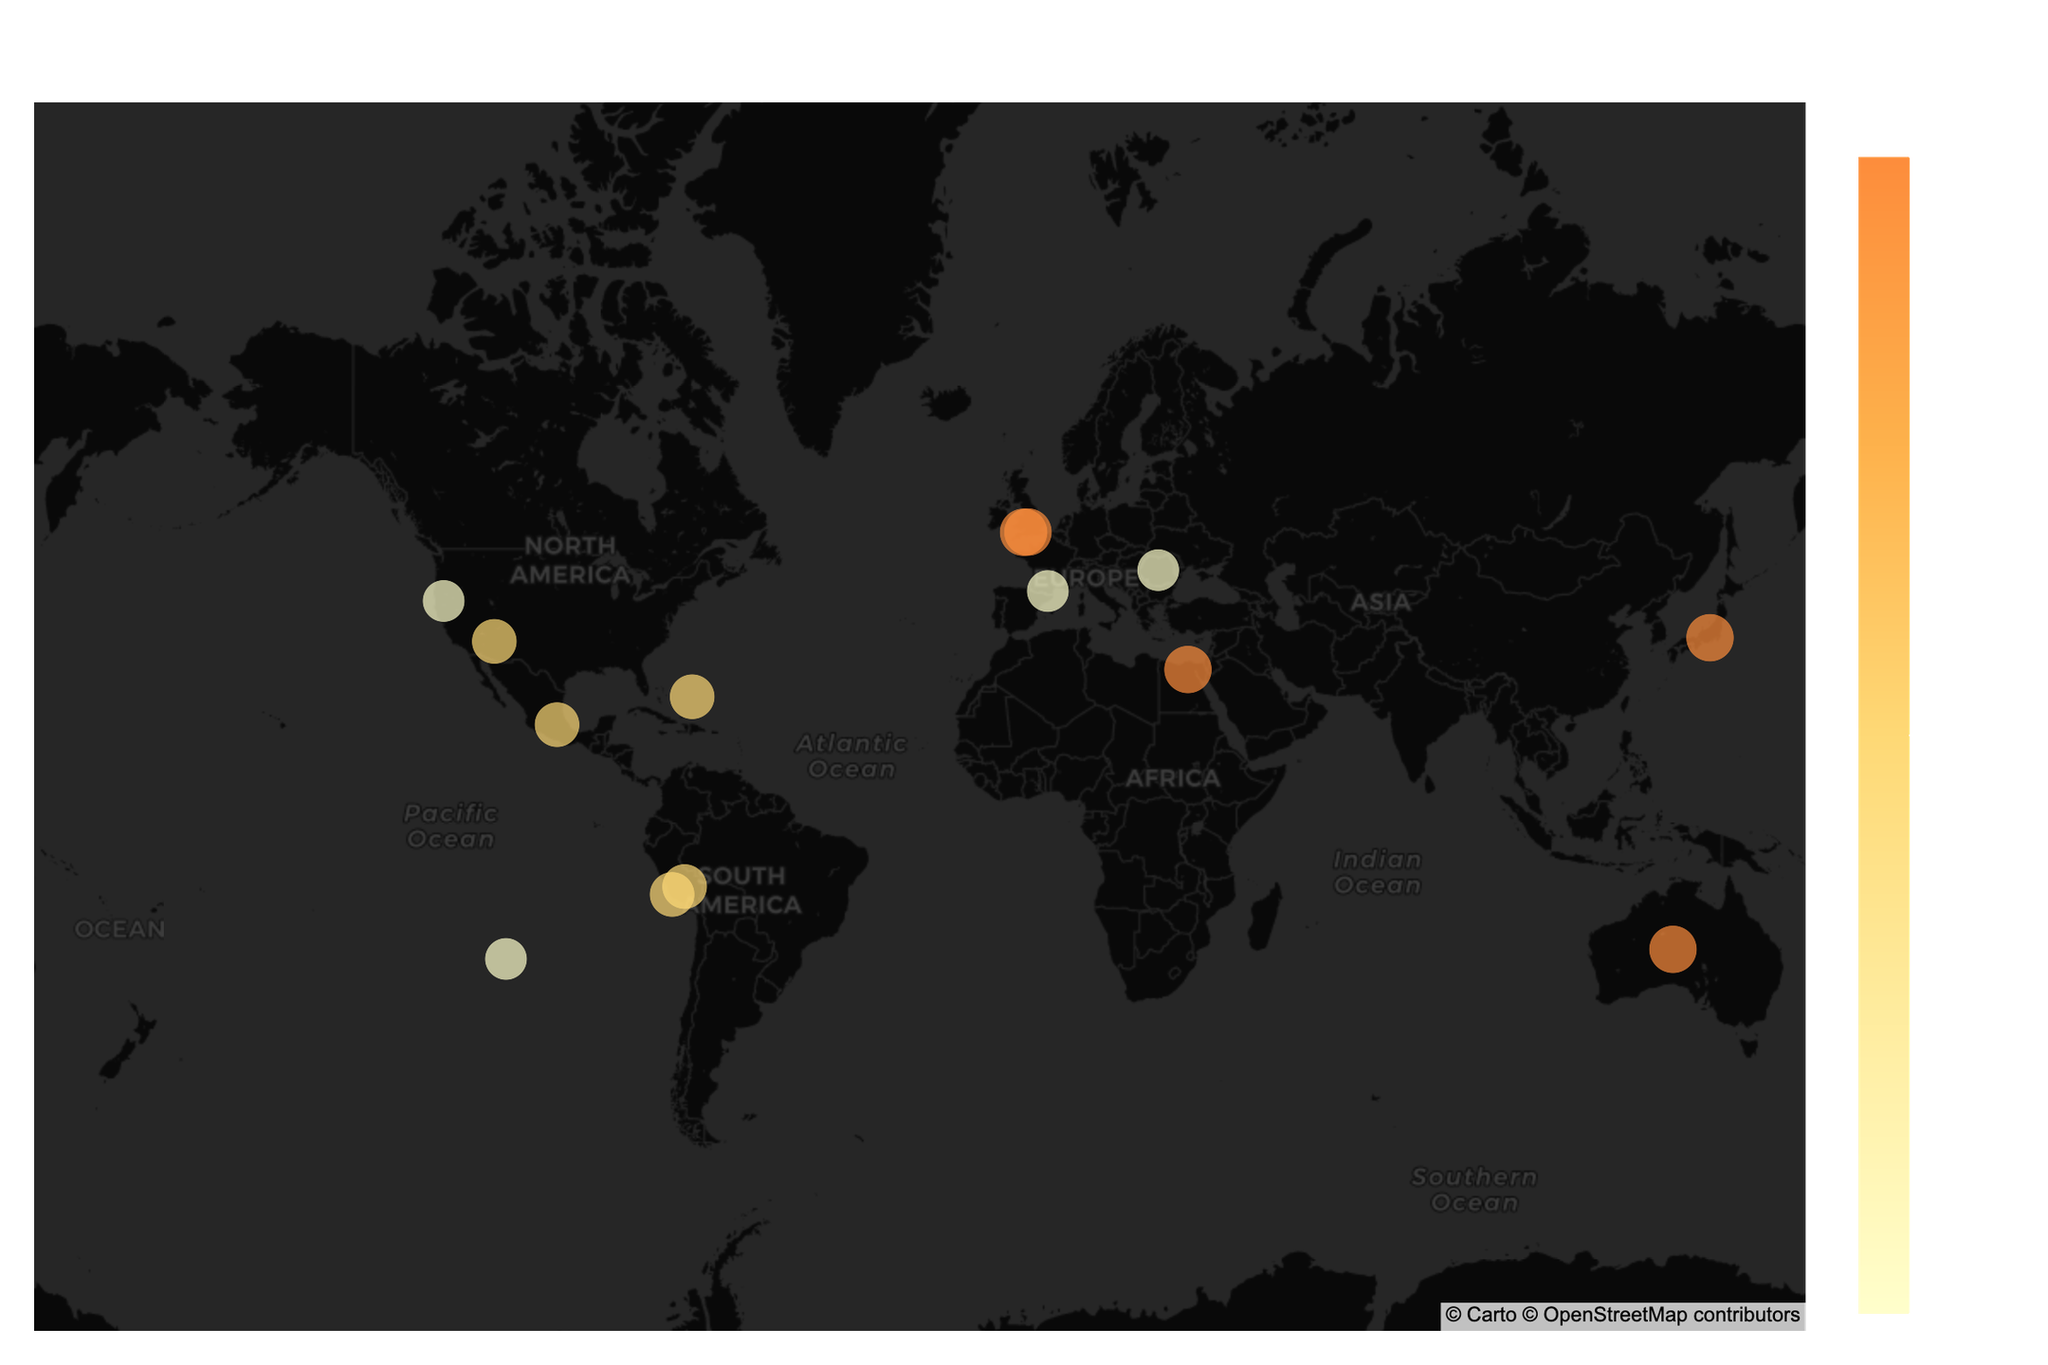What is the title of the figure? The title of the figure is displayed at the top and is usually the most prominent text in the plot. In this case, the title reads "Global Hotspots for Paranormal Activities and Unexplained Phenomena."
Answer: Global Hotspots for Paranormal Activities and Unexplained Phenomena How many locations are indicated as global hotspots for paranormal activity? To answer this, count the number of unique data points on the map, each representing a global hotspot.
Answer: 14 Which location has the highest intensity of paranormal activities? The intensity of paranormal activities is represented by color and size in the plot. By examining the data points, we see that both Glastonbury (UK), Aokigahara Forest (Japan), Uluru (Australia), Giza Plateau (Egypt), and Stonehenge (UK) have the highest intensity marked as 9.
Answer: Glastonbury (UK), Aokigahara Forest (Japan), Uluru (Australia), Giza Plateau (Egypt), Stonehenge (UK) What type of paranormal activity is observed in the Bermuda Triangle? Hovering over the Bermuda Triangle point on the map reveals detailed information including the type of paranormal activity, which in this case is "Mysterious Disappearances."
Answer: Mysterious Disappearances Which locations have an intensity level of 8? By observing the visual markers and possibly the color and size of the data points, you can identify the locations with an intensity of 8. These are Sedona (USA), Machu Picchu (Peru), Bermuda Triangle, Nazca Lines (Peru), and Teotihuacan (Mexico).
Answer: Sedona (USA), Machu Picchu (Peru), Bermuda Triangle, Nazca Lines (Peru), Teotihuacan (Mexico) How many locations in the dataset are in the USA? Look for the locations within the USA based on the map and location names. Sedona (USA) and Mount Shasta (USA) are the two American locations.
Answer: 2 Which locations in the plot show activities related to ancient civilizations or historical mystical beliefs? Review each location's "Type" attribute for keywords related to ancient civilizations or historical mystical beliefs, such as "Ancient Energy Fields," "Sacred Geometry," "Pyramid Energy," "Ancient Astronaut Theory," and "Megalithic Mystery." These activities are indicated at locations Machu Picchu (Peru), Rennes-le-Château (France), Giza Plateau (Egypt), Nazca Lines (Peru), and Easter Island (Chile).
Answer: Machu Picchu (Peru), Rennes-le-Château (France), Giza Plateau (Egypt), Nazca Lines (Peru), Easter Island (Chile) Which region of the world has the highest concentration of paranormal hotspots based on the geography represented in the plot? By visual inspection of the map, it is possible to infer that Europe has the highest concentration of locations (Glastonbury, Rennes-le-Château, Transylvania, and Stonehenge).
Answer: Europe What types of activities are linked to spirit manifestations and energy fields as per the plot? Cross-reference the "Type" column for occurrences of "Spirit Manifestations" and "Energy Fields." Aokigahara Forest (Japan) is linked to "Spirit Manifestations." Machu Picchu (Peru) and Sedona (USA) are linked to "Ancient Energy Fields" and "Vortex Energy," respectively.
Answer: Spirit Manifestations: Aokigahara Forest (Japan); Energy Fields: Machu Picchu (Peru), Sedona (USA) How do the maximum and minimum intensity levels compare among the locations, and which sites represent these extremes? From the plot, the intensity levels range from 7 to 9. The locations with the highest intensity (9) are Glastonbury, Aokigahara Forest, Uluru, Giza Plateau, and Stonehenge. The locations with the lowest intensity (7) are Mount Shasta, Rennes-le-Château, Transylvania, and Easter Island.
Answer: Maximum: Glastonbury, Aokigahara Forest, Uluru, Giza Plateau, Stonehenge; Minimum: Mount Shasta, Rennes-le-Château, Transylvania, Easter Island 